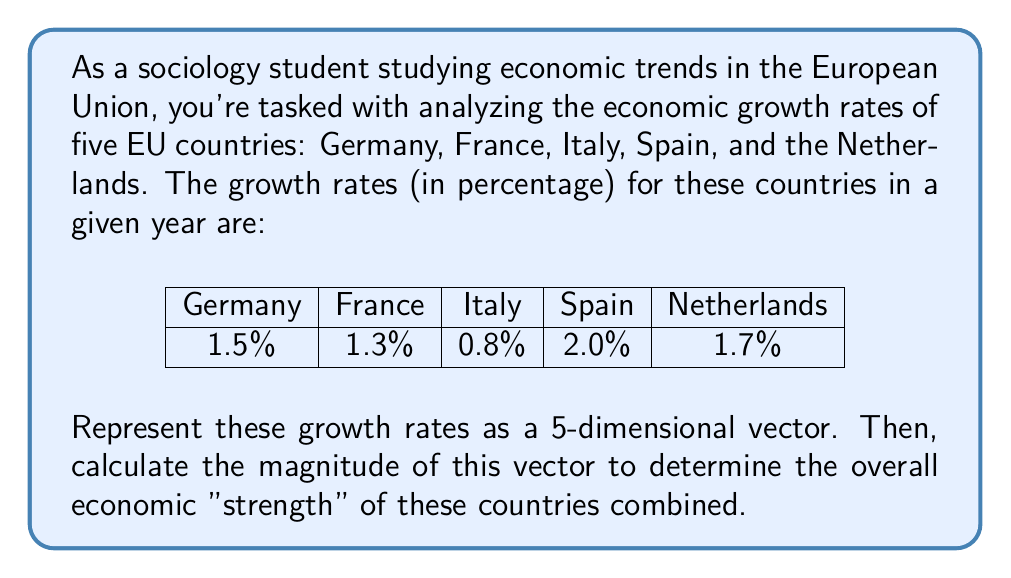Give your solution to this math problem. Let's approach this step-by-step:

1) First, we need to represent the growth rates as a vector. Each country's growth rate will be a component of our vector:

   $$\vec{v} = (1.5, 1.3, 0.8, 2.0, 1.7)$$

2) To calculate the magnitude of this vector, we use the formula:

   $$\|\vec{v}\| = \sqrt{v_1^2 + v_2^2 + v_3^2 + v_4^2 + v_5^2}$$

3) Let's substitute our values:

   $$\|\vec{v}\| = \sqrt{1.5^2 + 1.3^2 + 0.8^2 + 2.0^2 + 1.7^2}$$

4) Now let's calculate:

   $$\|\vec{v}\| = \sqrt{2.25 + 1.69 + 0.64 + 4.00 + 2.89}$$

5) Add up the values under the square root:

   $$\|\vec{v}\| = \sqrt{11.47}$$

6) Finally, calculate the square root:

   $$\|\vec{v}\| \approx 3.39$$

This value (3.39) represents the magnitude of our economic growth vector, which can be interpreted as a measure of the combined economic "strength" of these five countries in terms of their growth rates.
Answer: $\vec{v} = (1.5, 1.3, 0.8, 2.0, 1.7)$, $\|\vec{v}\| \approx 3.39$ 